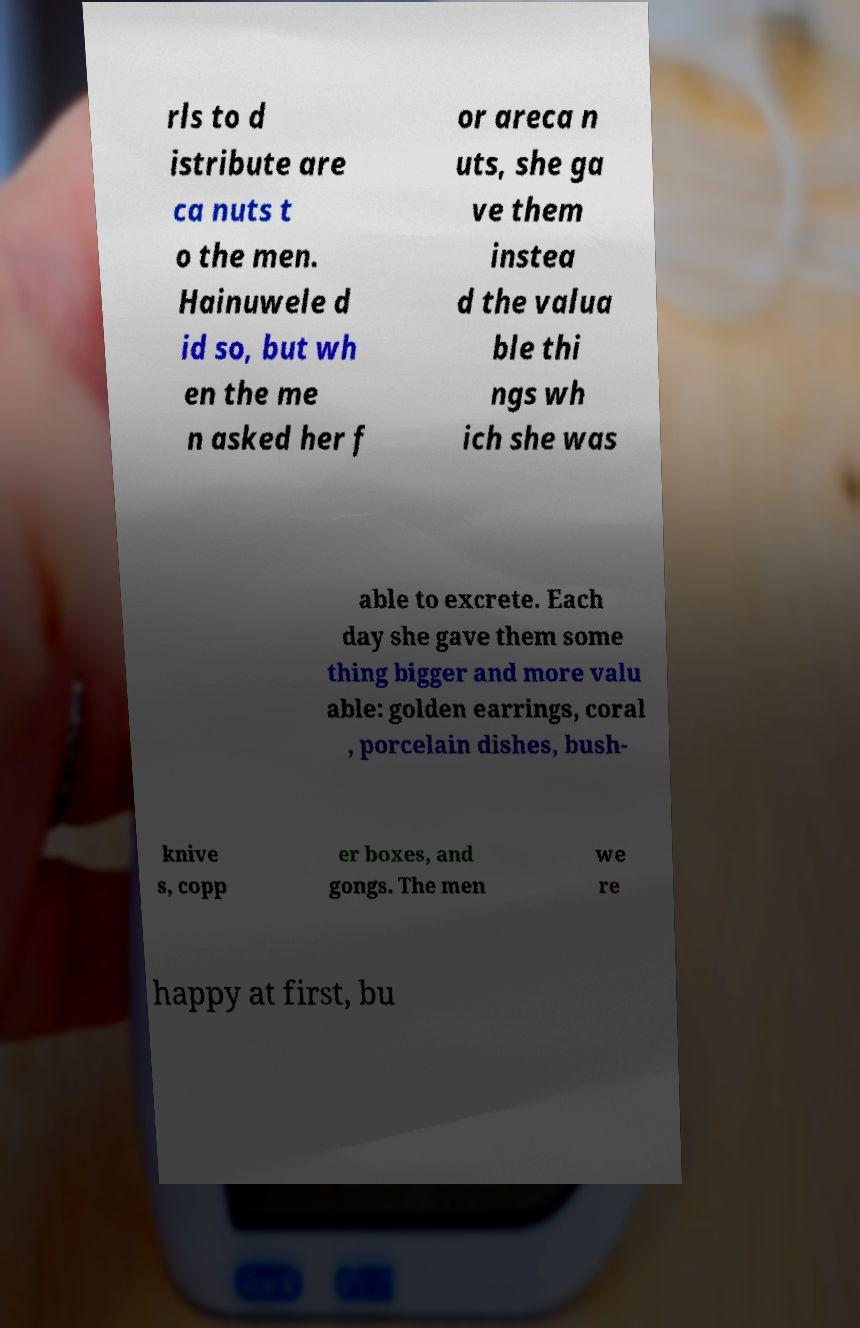What messages or text are displayed in this image? I need them in a readable, typed format. rls to d istribute are ca nuts t o the men. Hainuwele d id so, but wh en the me n asked her f or areca n uts, she ga ve them instea d the valua ble thi ngs wh ich she was able to excrete. Each day she gave them some thing bigger and more valu able: golden earrings, coral , porcelain dishes, bush- knive s, copp er boxes, and gongs. The men we re happy at first, bu 